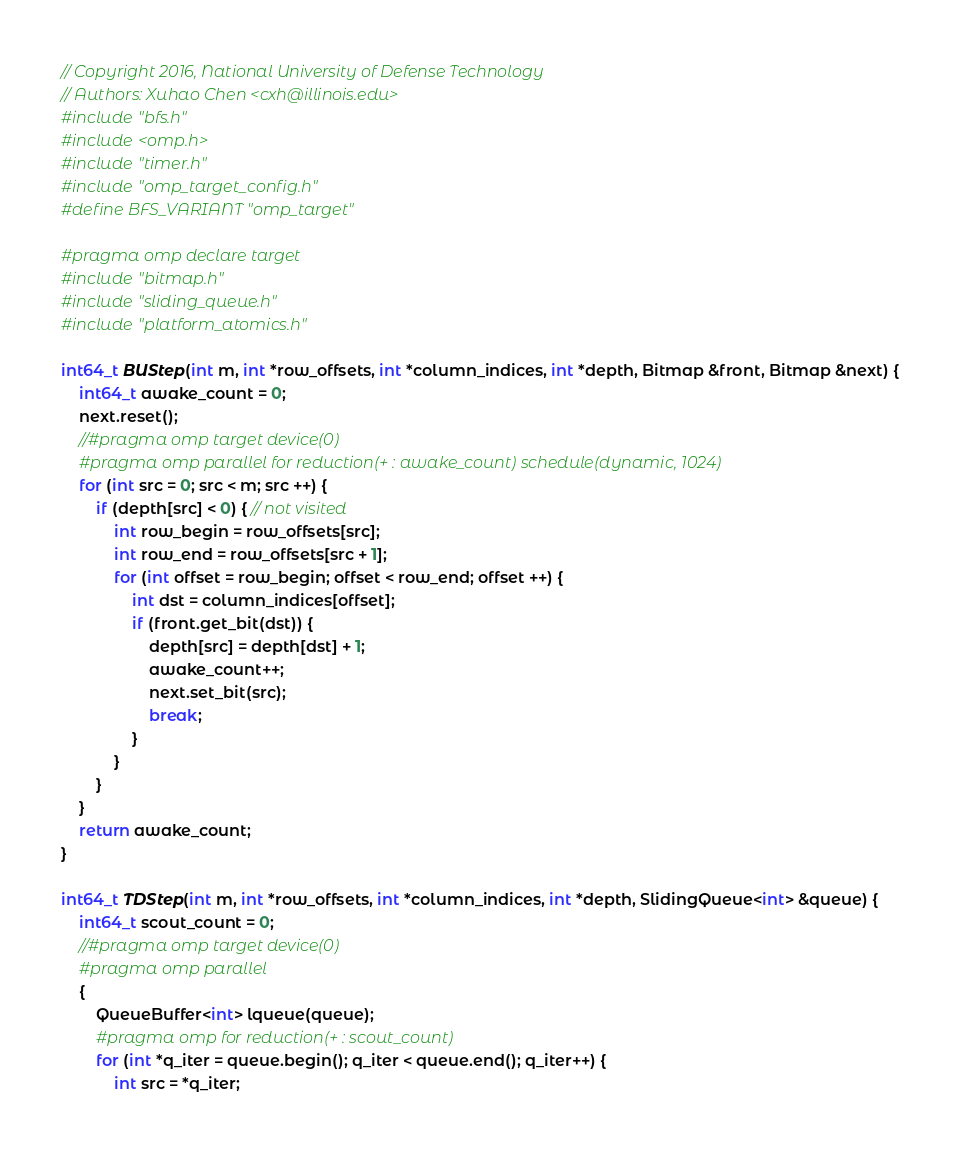Convert code to text. <code><loc_0><loc_0><loc_500><loc_500><_C++_>// Copyright 2016, National University of Defense Technology
// Authors: Xuhao Chen <cxh@illinois.edu>
#include "bfs.h"
#include <omp.h>
#include "timer.h"
#include "omp_target_config.h"
#define BFS_VARIANT "omp_target"

#pragma omp declare target
#include "bitmap.h"
#include "sliding_queue.h"
#include "platform_atomics.h"

int64_t BUStep(int m, int *row_offsets, int *column_indices, int *depth, Bitmap &front, Bitmap &next) {
	int64_t awake_count = 0;
	next.reset();
	//#pragma omp target device(0)
	#pragma omp parallel for reduction(+ : awake_count) schedule(dynamic, 1024)
	for (int src = 0; src < m; src ++) {
		if (depth[src] < 0) { // not visited
			int row_begin = row_offsets[src];
			int row_end = row_offsets[src + 1];
			for (int offset = row_begin; offset < row_end; offset ++) {
				int dst = column_indices[offset];
				if (front.get_bit(dst)) {
					depth[src] = depth[dst] + 1;
					awake_count++;
					next.set_bit(src);
					break;
				}
			}
		}
	}
	return awake_count;
}

int64_t TDStep(int m, int *row_offsets, int *column_indices, int *depth, SlidingQueue<int> &queue) {
	int64_t scout_count = 0;
	//#pragma omp target device(0)
	#pragma omp parallel
	{
		QueueBuffer<int> lqueue(queue);
		#pragma omp for reduction(+ : scout_count)
		for (int *q_iter = queue.begin(); q_iter < queue.end(); q_iter++) {
			int src = *q_iter;</code> 